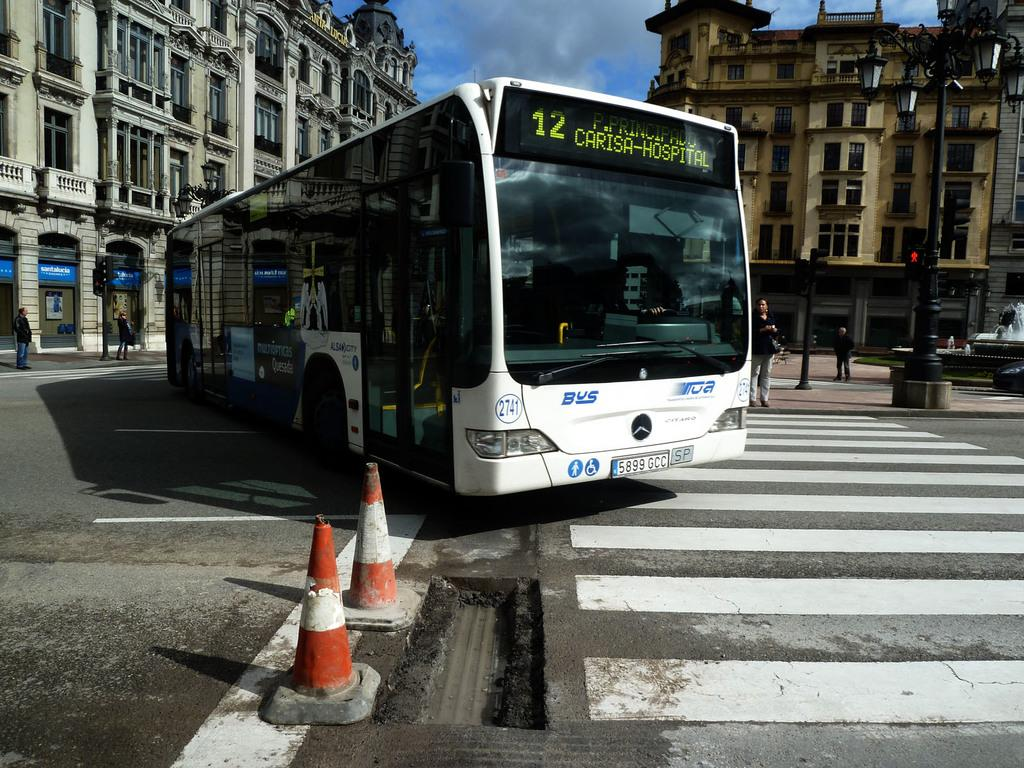<image>
Provide a brief description of the given image. The number 12 bus coming down a street in part of a old city. 